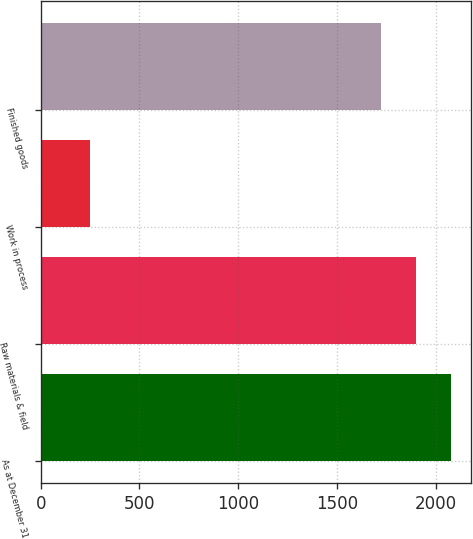Convert chart to OTSL. <chart><loc_0><loc_0><loc_500><loc_500><bar_chart><fcel>As at December 31<fcel>Raw materials & field<fcel>Work in process<fcel>Finished goods<nl><fcel>2074.2<fcel>1898.1<fcel>249<fcel>1722<nl></chart> 